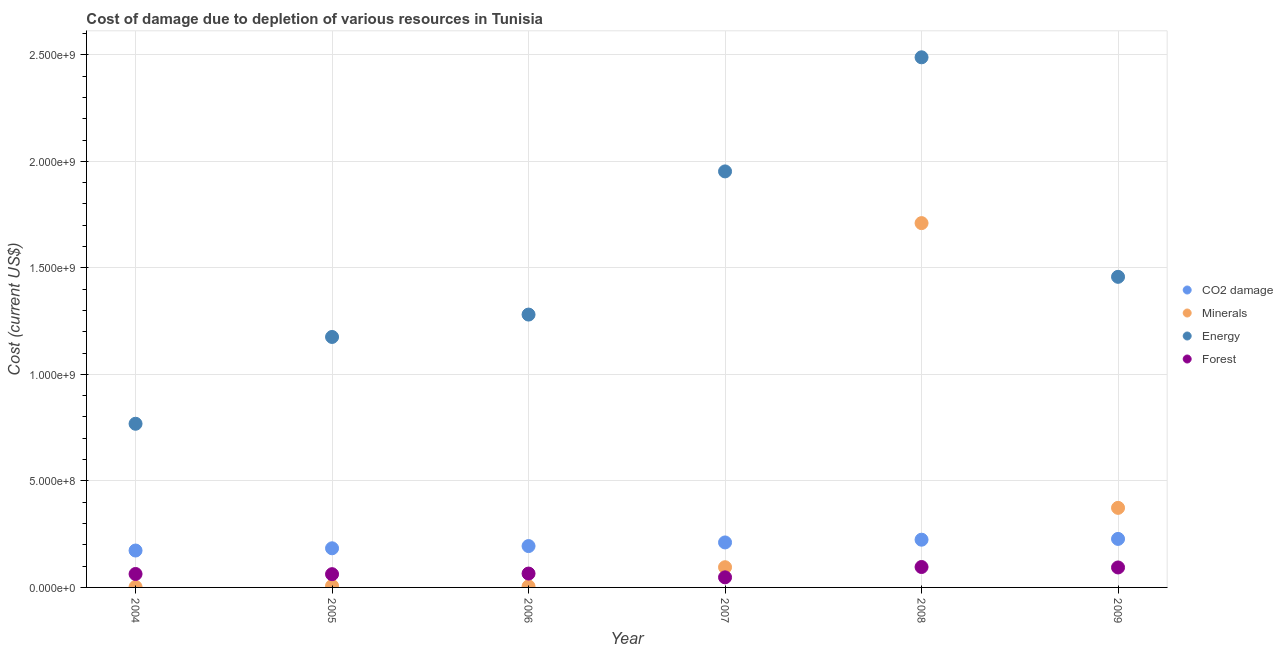Is the number of dotlines equal to the number of legend labels?
Provide a succinct answer. Yes. What is the cost of damage due to depletion of coal in 2009?
Keep it short and to the point. 2.28e+08. Across all years, what is the maximum cost of damage due to depletion of coal?
Provide a short and direct response. 2.28e+08. Across all years, what is the minimum cost of damage due to depletion of forests?
Offer a very short reply. 4.74e+07. In which year was the cost of damage due to depletion of minerals maximum?
Make the answer very short. 2008. What is the total cost of damage due to depletion of forests in the graph?
Keep it short and to the point. 4.27e+08. What is the difference between the cost of damage due to depletion of minerals in 2005 and that in 2007?
Offer a terse response. -8.79e+07. What is the difference between the cost of damage due to depletion of minerals in 2006 and the cost of damage due to depletion of energy in 2005?
Give a very brief answer. -1.17e+09. What is the average cost of damage due to depletion of forests per year?
Provide a succinct answer. 7.12e+07. In the year 2007, what is the difference between the cost of damage due to depletion of coal and cost of damage due to depletion of forests?
Your answer should be very brief. 1.64e+08. In how many years, is the cost of damage due to depletion of minerals greater than 800000000 US$?
Provide a succinct answer. 1. What is the ratio of the cost of damage due to depletion of minerals in 2006 to that in 2008?
Your answer should be very brief. 0. Is the cost of damage due to depletion of energy in 2004 less than that in 2007?
Ensure brevity in your answer.  Yes. What is the difference between the highest and the second highest cost of damage due to depletion of minerals?
Your answer should be very brief. 1.34e+09. What is the difference between the highest and the lowest cost of damage due to depletion of forests?
Keep it short and to the point. 4.85e+07. Is it the case that in every year, the sum of the cost of damage due to depletion of energy and cost of damage due to depletion of minerals is greater than the sum of cost of damage due to depletion of coal and cost of damage due to depletion of forests?
Give a very brief answer. No. Is it the case that in every year, the sum of the cost of damage due to depletion of coal and cost of damage due to depletion of minerals is greater than the cost of damage due to depletion of energy?
Your answer should be very brief. No. Does the cost of damage due to depletion of coal monotonically increase over the years?
Ensure brevity in your answer.  Yes. Is the cost of damage due to depletion of forests strictly less than the cost of damage due to depletion of coal over the years?
Your answer should be very brief. Yes. How many years are there in the graph?
Provide a succinct answer. 6. What is the difference between two consecutive major ticks on the Y-axis?
Your answer should be compact. 5.00e+08. Does the graph contain grids?
Your answer should be very brief. Yes. How many legend labels are there?
Your answer should be very brief. 4. What is the title of the graph?
Ensure brevity in your answer.  Cost of damage due to depletion of various resources in Tunisia . What is the label or title of the Y-axis?
Your answer should be very brief. Cost (current US$). What is the Cost (current US$) in CO2 damage in 2004?
Provide a succinct answer. 1.73e+08. What is the Cost (current US$) in Minerals in 2004?
Offer a terse response. 2.32e+06. What is the Cost (current US$) in Energy in 2004?
Offer a terse response. 7.68e+08. What is the Cost (current US$) in Forest in 2004?
Provide a short and direct response. 6.31e+07. What is the Cost (current US$) of CO2 damage in 2005?
Ensure brevity in your answer.  1.84e+08. What is the Cost (current US$) in Minerals in 2005?
Provide a succinct answer. 6.94e+06. What is the Cost (current US$) in Energy in 2005?
Provide a succinct answer. 1.18e+09. What is the Cost (current US$) of Forest in 2005?
Provide a short and direct response. 6.23e+07. What is the Cost (current US$) of CO2 damage in 2006?
Offer a very short reply. 1.94e+08. What is the Cost (current US$) in Minerals in 2006?
Give a very brief answer. 4.85e+06. What is the Cost (current US$) in Energy in 2006?
Provide a succinct answer. 1.28e+09. What is the Cost (current US$) in Forest in 2006?
Offer a very short reply. 6.51e+07. What is the Cost (current US$) of CO2 damage in 2007?
Your answer should be very brief. 2.11e+08. What is the Cost (current US$) in Minerals in 2007?
Ensure brevity in your answer.  9.48e+07. What is the Cost (current US$) in Energy in 2007?
Make the answer very short. 1.95e+09. What is the Cost (current US$) in Forest in 2007?
Provide a short and direct response. 4.74e+07. What is the Cost (current US$) in CO2 damage in 2008?
Your answer should be compact. 2.24e+08. What is the Cost (current US$) of Minerals in 2008?
Keep it short and to the point. 1.71e+09. What is the Cost (current US$) of Energy in 2008?
Provide a succinct answer. 2.49e+09. What is the Cost (current US$) in Forest in 2008?
Ensure brevity in your answer.  9.59e+07. What is the Cost (current US$) in CO2 damage in 2009?
Provide a succinct answer. 2.28e+08. What is the Cost (current US$) in Minerals in 2009?
Your answer should be very brief. 3.73e+08. What is the Cost (current US$) of Energy in 2009?
Offer a terse response. 1.46e+09. What is the Cost (current US$) in Forest in 2009?
Your response must be concise. 9.37e+07. Across all years, what is the maximum Cost (current US$) in CO2 damage?
Offer a very short reply. 2.28e+08. Across all years, what is the maximum Cost (current US$) of Minerals?
Provide a succinct answer. 1.71e+09. Across all years, what is the maximum Cost (current US$) in Energy?
Your response must be concise. 2.49e+09. Across all years, what is the maximum Cost (current US$) in Forest?
Offer a very short reply. 9.59e+07. Across all years, what is the minimum Cost (current US$) of CO2 damage?
Keep it short and to the point. 1.73e+08. Across all years, what is the minimum Cost (current US$) of Minerals?
Keep it short and to the point. 2.32e+06. Across all years, what is the minimum Cost (current US$) of Energy?
Offer a very short reply. 7.68e+08. Across all years, what is the minimum Cost (current US$) of Forest?
Make the answer very short. 4.74e+07. What is the total Cost (current US$) in CO2 damage in the graph?
Your answer should be very brief. 1.21e+09. What is the total Cost (current US$) in Minerals in the graph?
Offer a terse response. 2.19e+09. What is the total Cost (current US$) in Energy in the graph?
Make the answer very short. 9.12e+09. What is the total Cost (current US$) in Forest in the graph?
Give a very brief answer. 4.27e+08. What is the difference between the Cost (current US$) in CO2 damage in 2004 and that in 2005?
Your answer should be compact. -1.05e+07. What is the difference between the Cost (current US$) in Minerals in 2004 and that in 2005?
Your answer should be very brief. -4.63e+06. What is the difference between the Cost (current US$) in Energy in 2004 and that in 2005?
Make the answer very short. -4.07e+08. What is the difference between the Cost (current US$) of Forest in 2004 and that in 2005?
Keep it short and to the point. 8.33e+05. What is the difference between the Cost (current US$) in CO2 damage in 2004 and that in 2006?
Offer a very short reply. -2.09e+07. What is the difference between the Cost (current US$) of Minerals in 2004 and that in 2006?
Your response must be concise. -2.53e+06. What is the difference between the Cost (current US$) of Energy in 2004 and that in 2006?
Ensure brevity in your answer.  -5.13e+08. What is the difference between the Cost (current US$) of Forest in 2004 and that in 2006?
Your answer should be compact. -1.98e+06. What is the difference between the Cost (current US$) in CO2 damage in 2004 and that in 2007?
Offer a very short reply. -3.80e+07. What is the difference between the Cost (current US$) in Minerals in 2004 and that in 2007?
Provide a short and direct response. -9.25e+07. What is the difference between the Cost (current US$) of Energy in 2004 and that in 2007?
Ensure brevity in your answer.  -1.18e+09. What is the difference between the Cost (current US$) of Forest in 2004 and that in 2007?
Ensure brevity in your answer.  1.57e+07. What is the difference between the Cost (current US$) in CO2 damage in 2004 and that in 2008?
Give a very brief answer. -5.08e+07. What is the difference between the Cost (current US$) in Minerals in 2004 and that in 2008?
Offer a very short reply. -1.71e+09. What is the difference between the Cost (current US$) of Energy in 2004 and that in 2008?
Your response must be concise. -1.72e+09. What is the difference between the Cost (current US$) of Forest in 2004 and that in 2008?
Your response must be concise. -3.28e+07. What is the difference between the Cost (current US$) of CO2 damage in 2004 and that in 2009?
Make the answer very short. -5.45e+07. What is the difference between the Cost (current US$) in Minerals in 2004 and that in 2009?
Keep it short and to the point. -3.71e+08. What is the difference between the Cost (current US$) of Energy in 2004 and that in 2009?
Offer a terse response. -6.90e+08. What is the difference between the Cost (current US$) of Forest in 2004 and that in 2009?
Give a very brief answer. -3.06e+07. What is the difference between the Cost (current US$) of CO2 damage in 2005 and that in 2006?
Keep it short and to the point. -1.04e+07. What is the difference between the Cost (current US$) in Minerals in 2005 and that in 2006?
Your answer should be compact. 2.10e+06. What is the difference between the Cost (current US$) of Energy in 2005 and that in 2006?
Your answer should be very brief. -1.05e+08. What is the difference between the Cost (current US$) in Forest in 2005 and that in 2006?
Give a very brief answer. -2.81e+06. What is the difference between the Cost (current US$) in CO2 damage in 2005 and that in 2007?
Provide a short and direct response. -2.75e+07. What is the difference between the Cost (current US$) of Minerals in 2005 and that in 2007?
Keep it short and to the point. -8.79e+07. What is the difference between the Cost (current US$) of Energy in 2005 and that in 2007?
Your answer should be very brief. -7.77e+08. What is the difference between the Cost (current US$) in Forest in 2005 and that in 2007?
Your answer should be compact. 1.49e+07. What is the difference between the Cost (current US$) of CO2 damage in 2005 and that in 2008?
Provide a short and direct response. -4.03e+07. What is the difference between the Cost (current US$) of Minerals in 2005 and that in 2008?
Ensure brevity in your answer.  -1.70e+09. What is the difference between the Cost (current US$) in Energy in 2005 and that in 2008?
Your answer should be very brief. -1.31e+09. What is the difference between the Cost (current US$) of Forest in 2005 and that in 2008?
Your response must be concise. -3.36e+07. What is the difference between the Cost (current US$) in CO2 damage in 2005 and that in 2009?
Your response must be concise. -4.40e+07. What is the difference between the Cost (current US$) in Minerals in 2005 and that in 2009?
Give a very brief answer. -3.67e+08. What is the difference between the Cost (current US$) in Energy in 2005 and that in 2009?
Provide a succinct answer. -2.82e+08. What is the difference between the Cost (current US$) of Forest in 2005 and that in 2009?
Keep it short and to the point. -3.14e+07. What is the difference between the Cost (current US$) in CO2 damage in 2006 and that in 2007?
Offer a terse response. -1.71e+07. What is the difference between the Cost (current US$) in Minerals in 2006 and that in 2007?
Your answer should be very brief. -9.00e+07. What is the difference between the Cost (current US$) in Energy in 2006 and that in 2007?
Ensure brevity in your answer.  -6.72e+08. What is the difference between the Cost (current US$) in Forest in 2006 and that in 2007?
Your answer should be very brief. 1.77e+07. What is the difference between the Cost (current US$) of CO2 damage in 2006 and that in 2008?
Make the answer very short. -2.99e+07. What is the difference between the Cost (current US$) of Minerals in 2006 and that in 2008?
Your response must be concise. -1.71e+09. What is the difference between the Cost (current US$) of Energy in 2006 and that in 2008?
Your answer should be compact. -1.21e+09. What is the difference between the Cost (current US$) in Forest in 2006 and that in 2008?
Give a very brief answer. -3.08e+07. What is the difference between the Cost (current US$) in CO2 damage in 2006 and that in 2009?
Your response must be concise. -3.36e+07. What is the difference between the Cost (current US$) of Minerals in 2006 and that in 2009?
Make the answer very short. -3.69e+08. What is the difference between the Cost (current US$) of Energy in 2006 and that in 2009?
Offer a very short reply. -1.77e+08. What is the difference between the Cost (current US$) of Forest in 2006 and that in 2009?
Ensure brevity in your answer.  -2.86e+07. What is the difference between the Cost (current US$) in CO2 damage in 2007 and that in 2008?
Make the answer very short. -1.29e+07. What is the difference between the Cost (current US$) of Minerals in 2007 and that in 2008?
Make the answer very short. -1.62e+09. What is the difference between the Cost (current US$) in Energy in 2007 and that in 2008?
Ensure brevity in your answer.  -5.36e+08. What is the difference between the Cost (current US$) of Forest in 2007 and that in 2008?
Your response must be concise. -4.85e+07. What is the difference between the Cost (current US$) of CO2 damage in 2007 and that in 2009?
Keep it short and to the point. -1.66e+07. What is the difference between the Cost (current US$) of Minerals in 2007 and that in 2009?
Your answer should be very brief. -2.79e+08. What is the difference between the Cost (current US$) of Energy in 2007 and that in 2009?
Provide a succinct answer. 4.95e+08. What is the difference between the Cost (current US$) in Forest in 2007 and that in 2009?
Give a very brief answer. -4.63e+07. What is the difference between the Cost (current US$) of CO2 damage in 2008 and that in 2009?
Ensure brevity in your answer.  -3.70e+06. What is the difference between the Cost (current US$) in Minerals in 2008 and that in 2009?
Keep it short and to the point. 1.34e+09. What is the difference between the Cost (current US$) of Energy in 2008 and that in 2009?
Keep it short and to the point. 1.03e+09. What is the difference between the Cost (current US$) in Forest in 2008 and that in 2009?
Your response must be concise. 2.16e+06. What is the difference between the Cost (current US$) in CO2 damage in 2004 and the Cost (current US$) in Minerals in 2005?
Make the answer very short. 1.66e+08. What is the difference between the Cost (current US$) of CO2 damage in 2004 and the Cost (current US$) of Energy in 2005?
Ensure brevity in your answer.  -1.00e+09. What is the difference between the Cost (current US$) in CO2 damage in 2004 and the Cost (current US$) in Forest in 2005?
Give a very brief answer. 1.11e+08. What is the difference between the Cost (current US$) of Minerals in 2004 and the Cost (current US$) of Energy in 2005?
Keep it short and to the point. -1.17e+09. What is the difference between the Cost (current US$) of Minerals in 2004 and the Cost (current US$) of Forest in 2005?
Make the answer very short. -5.99e+07. What is the difference between the Cost (current US$) of Energy in 2004 and the Cost (current US$) of Forest in 2005?
Offer a terse response. 7.06e+08. What is the difference between the Cost (current US$) of CO2 damage in 2004 and the Cost (current US$) of Minerals in 2006?
Provide a short and direct response. 1.68e+08. What is the difference between the Cost (current US$) in CO2 damage in 2004 and the Cost (current US$) in Energy in 2006?
Make the answer very short. -1.11e+09. What is the difference between the Cost (current US$) in CO2 damage in 2004 and the Cost (current US$) in Forest in 2006?
Provide a succinct answer. 1.08e+08. What is the difference between the Cost (current US$) of Minerals in 2004 and the Cost (current US$) of Energy in 2006?
Make the answer very short. -1.28e+09. What is the difference between the Cost (current US$) of Minerals in 2004 and the Cost (current US$) of Forest in 2006?
Give a very brief answer. -6.27e+07. What is the difference between the Cost (current US$) in Energy in 2004 and the Cost (current US$) in Forest in 2006?
Keep it short and to the point. 7.03e+08. What is the difference between the Cost (current US$) of CO2 damage in 2004 and the Cost (current US$) of Minerals in 2007?
Ensure brevity in your answer.  7.84e+07. What is the difference between the Cost (current US$) in CO2 damage in 2004 and the Cost (current US$) in Energy in 2007?
Offer a terse response. -1.78e+09. What is the difference between the Cost (current US$) of CO2 damage in 2004 and the Cost (current US$) of Forest in 2007?
Provide a succinct answer. 1.26e+08. What is the difference between the Cost (current US$) of Minerals in 2004 and the Cost (current US$) of Energy in 2007?
Give a very brief answer. -1.95e+09. What is the difference between the Cost (current US$) of Minerals in 2004 and the Cost (current US$) of Forest in 2007?
Keep it short and to the point. -4.51e+07. What is the difference between the Cost (current US$) of Energy in 2004 and the Cost (current US$) of Forest in 2007?
Give a very brief answer. 7.21e+08. What is the difference between the Cost (current US$) in CO2 damage in 2004 and the Cost (current US$) in Minerals in 2008?
Your answer should be very brief. -1.54e+09. What is the difference between the Cost (current US$) in CO2 damage in 2004 and the Cost (current US$) in Energy in 2008?
Your answer should be very brief. -2.32e+09. What is the difference between the Cost (current US$) of CO2 damage in 2004 and the Cost (current US$) of Forest in 2008?
Give a very brief answer. 7.73e+07. What is the difference between the Cost (current US$) of Minerals in 2004 and the Cost (current US$) of Energy in 2008?
Provide a succinct answer. -2.49e+09. What is the difference between the Cost (current US$) in Minerals in 2004 and the Cost (current US$) in Forest in 2008?
Provide a short and direct response. -9.35e+07. What is the difference between the Cost (current US$) in Energy in 2004 and the Cost (current US$) in Forest in 2008?
Make the answer very short. 6.72e+08. What is the difference between the Cost (current US$) in CO2 damage in 2004 and the Cost (current US$) in Minerals in 2009?
Ensure brevity in your answer.  -2.00e+08. What is the difference between the Cost (current US$) in CO2 damage in 2004 and the Cost (current US$) in Energy in 2009?
Make the answer very short. -1.28e+09. What is the difference between the Cost (current US$) of CO2 damage in 2004 and the Cost (current US$) of Forest in 2009?
Offer a very short reply. 7.95e+07. What is the difference between the Cost (current US$) in Minerals in 2004 and the Cost (current US$) in Energy in 2009?
Offer a very short reply. -1.46e+09. What is the difference between the Cost (current US$) in Minerals in 2004 and the Cost (current US$) in Forest in 2009?
Offer a terse response. -9.14e+07. What is the difference between the Cost (current US$) in Energy in 2004 and the Cost (current US$) in Forest in 2009?
Your answer should be compact. 6.74e+08. What is the difference between the Cost (current US$) of CO2 damage in 2005 and the Cost (current US$) of Minerals in 2006?
Keep it short and to the point. 1.79e+08. What is the difference between the Cost (current US$) of CO2 damage in 2005 and the Cost (current US$) of Energy in 2006?
Make the answer very short. -1.10e+09. What is the difference between the Cost (current US$) in CO2 damage in 2005 and the Cost (current US$) in Forest in 2006?
Your answer should be very brief. 1.19e+08. What is the difference between the Cost (current US$) in Minerals in 2005 and the Cost (current US$) in Energy in 2006?
Offer a very short reply. -1.27e+09. What is the difference between the Cost (current US$) of Minerals in 2005 and the Cost (current US$) of Forest in 2006?
Keep it short and to the point. -5.81e+07. What is the difference between the Cost (current US$) in Energy in 2005 and the Cost (current US$) in Forest in 2006?
Offer a very short reply. 1.11e+09. What is the difference between the Cost (current US$) of CO2 damage in 2005 and the Cost (current US$) of Minerals in 2007?
Provide a succinct answer. 8.88e+07. What is the difference between the Cost (current US$) in CO2 damage in 2005 and the Cost (current US$) in Energy in 2007?
Provide a succinct answer. -1.77e+09. What is the difference between the Cost (current US$) of CO2 damage in 2005 and the Cost (current US$) of Forest in 2007?
Make the answer very short. 1.36e+08. What is the difference between the Cost (current US$) in Minerals in 2005 and the Cost (current US$) in Energy in 2007?
Ensure brevity in your answer.  -1.95e+09. What is the difference between the Cost (current US$) of Minerals in 2005 and the Cost (current US$) of Forest in 2007?
Offer a very short reply. -4.04e+07. What is the difference between the Cost (current US$) of Energy in 2005 and the Cost (current US$) of Forest in 2007?
Keep it short and to the point. 1.13e+09. What is the difference between the Cost (current US$) of CO2 damage in 2005 and the Cost (current US$) of Minerals in 2008?
Provide a short and direct response. -1.53e+09. What is the difference between the Cost (current US$) of CO2 damage in 2005 and the Cost (current US$) of Energy in 2008?
Your answer should be very brief. -2.30e+09. What is the difference between the Cost (current US$) in CO2 damage in 2005 and the Cost (current US$) in Forest in 2008?
Make the answer very short. 8.78e+07. What is the difference between the Cost (current US$) in Minerals in 2005 and the Cost (current US$) in Energy in 2008?
Ensure brevity in your answer.  -2.48e+09. What is the difference between the Cost (current US$) of Minerals in 2005 and the Cost (current US$) of Forest in 2008?
Ensure brevity in your answer.  -8.89e+07. What is the difference between the Cost (current US$) in Energy in 2005 and the Cost (current US$) in Forest in 2008?
Offer a very short reply. 1.08e+09. What is the difference between the Cost (current US$) in CO2 damage in 2005 and the Cost (current US$) in Minerals in 2009?
Offer a terse response. -1.90e+08. What is the difference between the Cost (current US$) in CO2 damage in 2005 and the Cost (current US$) in Energy in 2009?
Your answer should be very brief. -1.27e+09. What is the difference between the Cost (current US$) in CO2 damage in 2005 and the Cost (current US$) in Forest in 2009?
Provide a succinct answer. 9.00e+07. What is the difference between the Cost (current US$) in Minerals in 2005 and the Cost (current US$) in Energy in 2009?
Give a very brief answer. -1.45e+09. What is the difference between the Cost (current US$) in Minerals in 2005 and the Cost (current US$) in Forest in 2009?
Provide a succinct answer. -8.68e+07. What is the difference between the Cost (current US$) in Energy in 2005 and the Cost (current US$) in Forest in 2009?
Offer a terse response. 1.08e+09. What is the difference between the Cost (current US$) of CO2 damage in 2006 and the Cost (current US$) of Minerals in 2007?
Provide a short and direct response. 9.93e+07. What is the difference between the Cost (current US$) in CO2 damage in 2006 and the Cost (current US$) in Energy in 2007?
Offer a very short reply. -1.76e+09. What is the difference between the Cost (current US$) in CO2 damage in 2006 and the Cost (current US$) in Forest in 2007?
Give a very brief answer. 1.47e+08. What is the difference between the Cost (current US$) of Minerals in 2006 and the Cost (current US$) of Energy in 2007?
Your response must be concise. -1.95e+09. What is the difference between the Cost (current US$) in Minerals in 2006 and the Cost (current US$) in Forest in 2007?
Provide a short and direct response. -4.25e+07. What is the difference between the Cost (current US$) in Energy in 2006 and the Cost (current US$) in Forest in 2007?
Keep it short and to the point. 1.23e+09. What is the difference between the Cost (current US$) of CO2 damage in 2006 and the Cost (current US$) of Minerals in 2008?
Offer a terse response. -1.52e+09. What is the difference between the Cost (current US$) of CO2 damage in 2006 and the Cost (current US$) of Energy in 2008?
Keep it short and to the point. -2.29e+09. What is the difference between the Cost (current US$) of CO2 damage in 2006 and the Cost (current US$) of Forest in 2008?
Your answer should be very brief. 9.82e+07. What is the difference between the Cost (current US$) of Minerals in 2006 and the Cost (current US$) of Energy in 2008?
Ensure brevity in your answer.  -2.48e+09. What is the difference between the Cost (current US$) of Minerals in 2006 and the Cost (current US$) of Forest in 2008?
Offer a terse response. -9.10e+07. What is the difference between the Cost (current US$) of Energy in 2006 and the Cost (current US$) of Forest in 2008?
Provide a succinct answer. 1.18e+09. What is the difference between the Cost (current US$) of CO2 damage in 2006 and the Cost (current US$) of Minerals in 2009?
Offer a very short reply. -1.79e+08. What is the difference between the Cost (current US$) of CO2 damage in 2006 and the Cost (current US$) of Energy in 2009?
Provide a succinct answer. -1.26e+09. What is the difference between the Cost (current US$) of CO2 damage in 2006 and the Cost (current US$) of Forest in 2009?
Make the answer very short. 1.00e+08. What is the difference between the Cost (current US$) of Minerals in 2006 and the Cost (current US$) of Energy in 2009?
Make the answer very short. -1.45e+09. What is the difference between the Cost (current US$) in Minerals in 2006 and the Cost (current US$) in Forest in 2009?
Give a very brief answer. -8.89e+07. What is the difference between the Cost (current US$) in Energy in 2006 and the Cost (current US$) in Forest in 2009?
Offer a terse response. 1.19e+09. What is the difference between the Cost (current US$) of CO2 damage in 2007 and the Cost (current US$) of Minerals in 2008?
Offer a very short reply. -1.50e+09. What is the difference between the Cost (current US$) in CO2 damage in 2007 and the Cost (current US$) in Energy in 2008?
Give a very brief answer. -2.28e+09. What is the difference between the Cost (current US$) in CO2 damage in 2007 and the Cost (current US$) in Forest in 2008?
Give a very brief answer. 1.15e+08. What is the difference between the Cost (current US$) of Minerals in 2007 and the Cost (current US$) of Energy in 2008?
Make the answer very short. -2.39e+09. What is the difference between the Cost (current US$) in Minerals in 2007 and the Cost (current US$) in Forest in 2008?
Offer a terse response. -1.02e+06. What is the difference between the Cost (current US$) in Energy in 2007 and the Cost (current US$) in Forest in 2008?
Your answer should be very brief. 1.86e+09. What is the difference between the Cost (current US$) in CO2 damage in 2007 and the Cost (current US$) in Minerals in 2009?
Keep it short and to the point. -1.62e+08. What is the difference between the Cost (current US$) in CO2 damage in 2007 and the Cost (current US$) in Energy in 2009?
Your response must be concise. -1.25e+09. What is the difference between the Cost (current US$) in CO2 damage in 2007 and the Cost (current US$) in Forest in 2009?
Your answer should be very brief. 1.17e+08. What is the difference between the Cost (current US$) in Minerals in 2007 and the Cost (current US$) in Energy in 2009?
Give a very brief answer. -1.36e+09. What is the difference between the Cost (current US$) of Minerals in 2007 and the Cost (current US$) of Forest in 2009?
Your response must be concise. 1.14e+06. What is the difference between the Cost (current US$) of Energy in 2007 and the Cost (current US$) of Forest in 2009?
Keep it short and to the point. 1.86e+09. What is the difference between the Cost (current US$) of CO2 damage in 2008 and the Cost (current US$) of Minerals in 2009?
Provide a succinct answer. -1.49e+08. What is the difference between the Cost (current US$) of CO2 damage in 2008 and the Cost (current US$) of Energy in 2009?
Your response must be concise. -1.23e+09. What is the difference between the Cost (current US$) in CO2 damage in 2008 and the Cost (current US$) in Forest in 2009?
Offer a terse response. 1.30e+08. What is the difference between the Cost (current US$) of Minerals in 2008 and the Cost (current US$) of Energy in 2009?
Give a very brief answer. 2.52e+08. What is the difference between the Cost (current US$) in Minerals in 2008 and the Cost (current US$) in Forest in 2009?
Offer a very short reply. 1.62e+09. What is the difference between the Cost (current US$) in Energy in 2008 and the Cost (current US$) in Forest in 2009?
Your response must be concise. 2.39e+09. What is the average Cost (current US$) in CO2 damage per year?
Ensure brevity in your answer.  2.02e+08. What is the average Cost (current US$) of Minerals per year?
Offer a very short reply. 3.65e+08. What is the average Cost (current US$) of Energy per year?
Your response must be concise. 1.52e+09. What is the average Cost (current US$) in Forest per year?
Make the answer very short. 7.12e+07. In the year 2004, what is the difference between the Cost (current US$) of CO2 damage and Cost (current US$) of Minerals?
Your response must be concise. 1.71e+08. In the year 2004, what is the difference between the Cost (current US$) in CO2 damage and Cost (current US$) in Energy?
Offer a very short reply. -5.95e+08. In the year 2004, what is the difference between the Cost (current US$) in CO2 damage and Cost (current US$) in Forest?
Ensure brevity in your answer.  1.10e+08. In the year 2004, what is the difference between the Cost (current US$) of Minerals and Cost (current US$) of Energy?
Offer a terse response. -7.66e+08. In the year 2004, what is the difference between the Cost (current US$) of Minerals and Cost (current US$) of Forest?
Make the answer very short. -6.08e+07. In the year 2004, what is the difference between the Cost (current US$) of Energy and Cost (current US$) of Forest?
Provide a short and direct response. 7.05e+08. In the year 2005, what is the difference between the Cost (current US$) of CO2 damage and Cost (current US$) of Minerals?
Ensure brevity in your answer.  1.77e+08. In the year 2005, what is the difference between the Cost (current US$) in CO2 damage and Cost (current US$) in Energy?
Ensure brevity in your answer.  -9.92e+08. In the year 2005, what is the difference between the Cost (current US$) of CO2 damage and Cost (current US$) of Forest?
Ensure brevity in your answer.  1.21e+08. In the year 2005, what is the difference between the Cost (current US$) of Minerals and Cost (current US$) of Energy?
Keep it short and to the point. -1.17e+09. In the year 2005, what is the difference between the Cost (current US$) of Minerals and Cost (current US$) of Forest?
Your answer should be very brief. -5.53e+07. In the year 2005, what is the difference between the Cost (current US$) of Energy and Cost (current US$) of Forest?
Keep it short and to the point. 1.11e+09. In the year 2006, what is the difference between the Cost (current US$) in CO2 damage and Cost (current US$) in Minerals?
Give a very brief answer. 1.89e+08. In the year 2006, what is the difference between the Cost (current US$) of CO2 damage and Cost (current US$) of Energy?
Ensure brevity in your answer.  -1.09e+09. In the year 2006, what is the difference between the Cost (current US$) of CO2 damage and Cost (current US$) of Forest?
Keep it short and to the point. 1.29e+08. In the year 2006, what is the difference between the Cost (current US$) of Minerals and Cost (current US$) of Energy?
Keep it short and to the point. -1.28e+09. In the year 2006, what is the difference between the Cost (current US$) of Minerals and Cost (current US$) of Forest?
Your answer should be very brief. -6.02e+07. In the year 2006, what is the difference between the Cost (current US$) in Energy and Cost (current US$) in Forest?
Provide a succinct answer. 1.22e+09. In the year 2007, what is the difference between the Cost (current US$) in CO2 damage and Cost (current US$) in Minerals?
Offer a terse response. 1.16e+08. In the year 2007, what is the difference between the Cost (current US$) of CO2 damage and Cost (current US$) of Energy?
Make the answer very short. -1.74e+09. In the year 2007, what is the difference between the Cost (current US$) in CO2 damage and Cost (current US$) in Forest?
Keep it short and to the point. 1.64e+08. In the year 2007, what is the difference between the Cost (current US$) in Minerals and Cost (current US$) in Energy?
Provide a succinct answer. -1.86e+09. In the year 2007, what is the difference between the Cost (current US$) of Minerals and Cost (current US$) of Forest?
Keep it short and to the point. 4.75e+07. In the year 2007, what is the difference between the Cost (current US$) of Energy and Cost (current US$) of Forest?
Provide a succinct answer. 1.91e+09. In the year 2008, what is the difference between the Cost (current US$) of CO2 damage and Cost (current US$) of Minerals?
Ensure brevity in your answer.  -1.49e+09. In the year 2008, what is the difference between the Cost (current US$) in CO2 damage and Cost (current US$) in Energy?
Your answer should be compact. -2.26e+09. In the year 2008, what is the difference between the Cost (current US$) in CO2 damage and Cost (current US$) in Forest?
Ensure brevity in your answer.  1.28e+08. In the year 2008, what is the difference between the Cost (current US$) in Minerals and Cost (current US$) in Energy?
Make the answer very short. -7.78e+08. In the year 2008, what is the difference between the Cost (current US$) of Minerals and Cost (current US$) of Forest?
Your answer should be compact. 1.61e+09. In the year 2008, what is the difference between the Cost (current US$) in Energy and Cost (current US$) in Forest?
Offer a very short reply. 2.39e+09. In the year 2009, what is the difference between the Cost (current US$) in CO2 damage and Cost (current US$) in Minerals?
Provide a succinct answer. -1.46e+08. In the year 2009, what is the difference between the Cost (current US$) in CO2 damage and Cost (current US$) in Energy?
Provide a short and direct response. -1.23e+09. In the year 2009, what is the difference between the Cost (current US$) in CO2 damage and Cost (current US$) in Forest?
Provide a succinct answer. 1.34e+08. In the year 2009, what is the difference between the Cost (current US$) of Minerals and Cost (current US$) of Energy?
Provide a succinct answer. -1.08e+09. In the year 2009, what is the difference between the Cost (current US$) of Minerals and Cost (current US$) of Forest?
Provide a succinct answer. 2.80e+08. In the year 2009, what is the difference between the Cost (current US$) in Energy and Cost (current US$) in Forest?
Your answer should be very brief. 1.36e+09. What is the ratio of the Cost (current US$) of CO2 damage in 2004 to that in 2005?
Offer a very short reply. 0.94. What is the ratio of the Cost (current US$) of Minerals in 2004 to that in 2005?
Provide a succinct answer. 0.33. What is the ratio of the Cost (current US$) of Energy in 2004 to that in 2005?
Provide a succinct answer. 0.65. What is the ratio of the Cost (current US$) of Forest in 2004 to that in 2005?
Ensure brevity in your answer.  1.01. What is the ratio of the Cost (current US$) in CO2 damage in 2004 to that in 2006?
Give a very brief answer. 0.89. What is the ratio of the Cost (current US$) of Minerals in 2004 to that in 2006?
Provide a succinct answer. 0.48. What is the ratio of the Cost (current US$) in Energy in 2004 to that in 2006?
Your response must be concise. 0.6. What is the ratio of the Cost (current US$) of Forest in 2004 to that in 2006?
Your answer should be very brief. 0.97. What is the ratio of the Cost (current US$) of CO2 damage in 2004 to that in 2007?
Make the answer very short. 0.82. What is the ratio of the Cost (current US$) in Minerals in 2004 to that in 2007?
Offer a very short reply. 0.02. What is the ratio of the Cost (current US$) in Energy in 2004 to that in 2007?
Offer a very short reply. 0.39. What is the ratio of the Cost (current US$) of Forest in 2004 to that in 2007?
Ensure brevity in your answer.  1.33. What is the ratio of the Cost (current US$) of CO2 damage in 2004 to that in 2008?
Your response must be concise. 0.77. What is the ratio of the Cost (current US$) of Minerals in 2004 to that in 2008?
Offer a terse response. 0. What is the ratio of the Cost (current US$) in Energy in 2004 to that in 2008?
Make the answer very short. 0.31. What is the ratio of the Cost (current US$) of Forest in 2004 to that in 2008?
Ensure brevity in your answer.  0.66. What is the ratio of the Cost (current US$) in CO2 damage in 2004 to that in 2009?
Offer a terse response. 0.76. What is the ratio of the Cost (current US$) in Minerals in 2004 to that in 2009?
Your response must be concise. 0.01. What is the ratio of the Cost (current US$) in Energy in 2004 to that in 2009?
Your answer should be compact. 0.53. What is the ratio of the Cost (current US$) of Forest in 2004 to that in 2009?
Make the answer very short. 0.67. What is the ratio of the Cost (current US$) in CO2 damage in 2005 to that in 2006?
Keep it short and to the point. 0.95. What is the ratio of the Cost (current US$) in Minerals in 2005 to that in 2006?
Offer a terse response. 1.43. What is the ratio of the Cost (current US$) of Energy in 2005 to that in 2006?
Offer a very short reply. 0.92. What is the ratio of the Cost (current US$) in Forest in 2005 to that in 2006?
Provide a succinct answer. 0.96. What is the ratio of the Cost (current US$) in CO2 damage in 2005 to that in 2007?
Offer a terse response. 0.87. What is the ratio of the Cost (current US$) of Minerals in 2005 to that in 2007?
Your answer should be very brief. 0.07. What is the ratio of the Cost (current US$) of Energy in 2005 to that in 2007?
Your answer should be very brief. 0.6. What is the ratio of the Cost (current US$) in Forest in 2005 to that in 2007?
Your response must be concise. 1.31. What is the ratio of the Cost (current US$) in CO2 damage in 2005 to that in 2008?
Ensure brevity in your answer.  0.82. What is the ratio of the Cost (current US$) in Minerals in 2005 to that in 2008?
Your answer should be very brief. 0. What is the ratio of the Cost (current US$) of Energy in 2005 to that in 2008?
Your response must be concise. 0.47. What is the ratio of the Cost (current US$) in Forest in 2005 to that in 2008?
Provide a short and direct response. 0.65. What is the ratio of the Cost (current US$) in CO2 damage in 2005 to that in 2009?
Ensure brevity in your answer.  0.81. What is the ratio of the Cost (current US$) in Minerals in 2005 to that in 2009?
Offer a terse response. 0.02. What is the ratio of the Cost (current US$) in Energy in 2005 to that in 2009?
Give a very brief answer. 0.81. What is the ratio of the Cost (current US$) in Forest in 2005 to that in 2009?
Keep it short and to the point. 0.66. What is the ratio of the Cost (current US$) in CO2 damage in 2006 to that in 2007?
Offer a very short reply. 0.92. What is the ratio of the Cost (current US$) in Minerals in 2006 to that in 2007?
Give a very brief answer. 0.05. What is the ratio of the Cost (current US$) of Energy in 2006 to that in 2007?
Offer a terse response. 0.66. What is the ratio of the Cost (current US$) of Forest in 2006 to that in 2007?
Your answer should be very brief. 1.37. What is the ratio of the Cost (current US$) in CO2 damage in 2006 to that in 2008?
Ensure brevity in your answer.  0.87. What is the ratio of the Cost (current US$) of Minerals in 2006 to that in 2008?
Provide a short and direct response. 0. What is the ratio of the Cost (current US$) of Energy in 2006 to that in 2008?
Your answer should be very brief. 0.51. What is the ratio of the Cost (current US$) in Forest in 2006 to that in 2008?
Your answer should be very brief. 0.68. What is the ratio of the Cost (current US$) in CO2 damage in 2006 to that in 2009?
Your answer should be very brief. 0.85. What is the ratio of the Cost (current US$) in Minerals in 2006 to that in 2009?
Give a very brief answer. 0.01. What is the ratio of the Cost (current US$) in Energy in 2006 to that in 2009?
Offer a terse response. 0.88. What is the ratio of the Cost (current US$) in Forest in 2006 to that in 2009?
Ensure brevity in your answer.  0.69. What is the ratio of the Cost (current US$) in CO2 damage in 2007 to that in 2008?
Your answer should be very brief. 0.94. What is the ratio of the Cost (current US$) of Minerals in 2007 to that in 2008?
Your answer should be compact. 0.06. What is the ratio of the Cost (current US$) of Energy in 2007 to that in 2008?
Offer a very short reply. 0.78. What is the ratio of the Cost (current US$) of Forest in 2007 to that in 2008?
Your answer should be very brief. 0.49. What is the ratio of the Cost (current US$) in CO2 damage in 2007 to that in 2009?
Offer a very short reply. 0.93. What is the ratio of the Cost (current US$) in Minerals in 2007 to that in 2009?
Provide a succinct answer. 0.25. What is the ratio of the Cost (current US$) of Energy in 2007 to that in 2009?
Provide a succinct answer. 1.34. What is the ratio of the Cost (current US$) of Forest in 2007 to that in 2009?
Make the answer very short. 0.51. What is the ratio of the Cost (current US$) of CO2 damage in 2008 to that in 2009?
Keep it short and to the point. 0.98. What is the ratio of the Cost (current US$) in Minerals in 2008 to that in 2009?
Ensure brevity in your answer.  4.58. What is the ratio of the Cost (current US$) in Energy in 2008 to that in 2009?
Offer a terse response. 1.71. What is the difference between the highest and the second highest Cost (current US$) of CO2 damage?
Keep it short and to the point. 3.70e+06. What is the difference between the highest and the second highest Cost (current US$) in Minerals?
Ensure brevity in your answer.  1.34e+09. What is the difference between the highest and the second highest Cost (current US$) in Energy?
Keep it short and to the point. 5.36e+08. What is the difference between the highest and the second highest Cost (current US$) of Forest?
Ensure brevity in your answer.  2.16e+06. What is the difference between the highest and the lowest Cost (current US$) in CO2 damage?
Ensure brevity in your answer.  5.45e+07. What is the difference between the highest and the lowest Cost (current US$) in Minerals?
Offer a very short reply. 1.71e+09. What is the difference between the highest and the lowest Cost (current US$) in Energy?
Keep it short and to the point. 1.72e+09. What is the difference between the highest and the lowest Cost (current US$) in Forest?
Ensure brevity in your answer.  4.85e+07. 